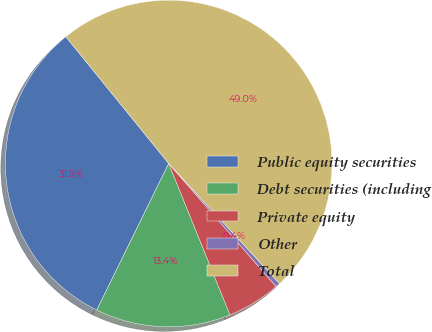<chart> <loc_0><loc_0><loc_500><loc_500><pie_chart><fcel>Public equity securities<fcel>Debt securities (including<fcel>Private equity<fcel>Other<fcel>Total<nl><fcel>31.89%<fcel>13.38%<fcel>5.3%<fcel>0.44%<fcel>48.99%<nl></chart> 